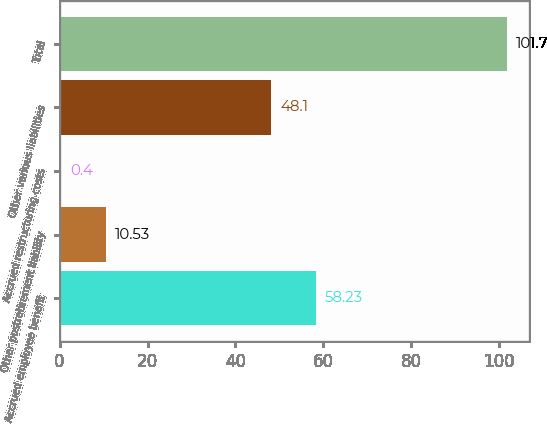Convert chart to OTSL. <chart><loc_0><loc_0><loc_500><loc_500><bar_chart><fcel>Accrued employee benefit<fcel>Other postretirement liability<fcel>Accrued restructuring costs<fcel>Other various liabilities<fcel>Total<nl><fcel>58.23<fcel>10.53<fcel>0.4<fcel>48.1<fcel>101.7<nl></chart> 